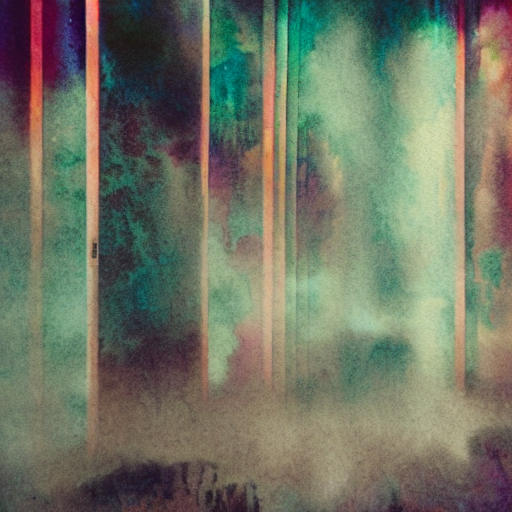Could this image be used in any commercial or decorative context? Absolutely, this image has the potential to be leveraged in a commercial or decorative context due to its abstract and atmospheric qualities. It could serve as a compelling backdrop for marketing materials in industries that value creativity and abstract thinking, such as design or advertising. Additionally, its aesthetic might appeal to those seeking modern, minimalist art for interior decor, possibly as a focal piece in a living room or an office space where it can stimulate conversation and reflection. 